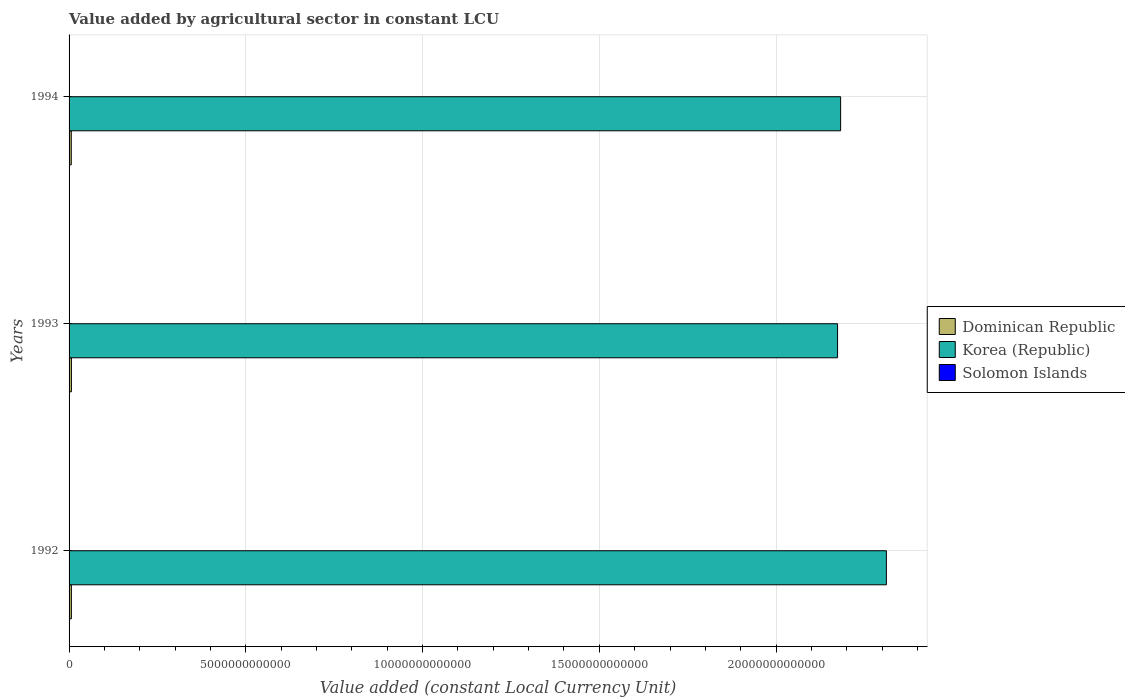How many different coloured bars are there?
Offer a very short reply. 3. Are the number of bars per tick equal to the number of legend labels?
Offer a terse response. Yes. Are the number of bars on each tick of the Y-axis equal?
Offer a very short reply. Yes. How many bars are there on the 2nd tick from the bottom?
Make the answer very short. 3. What is the value added by agricultural sector in Dominican Republic in 1993?
Provide a succinct answer. 6.63e+1. Across all years, what is the maximum value added by agricultural sector in Solomon Islands?
Keep it short and to the point. 7.80e+08. Across all years, what is the minimum value added by agricultural sector in Korea (Republic)?
Keep it short and to the point. 2.17e+13. In which year was the value added by agricultural sector in Solomon Islands minimum?
Offer a very short reply. 1993. What is the total value added by agricultural sector in Dominican Republic in the graph?
Your answer should be compact. 1.94e+11. What is the difference between the value added by agricultural sector in Solomon Islands in 1993 and that in 1994?
Offer a terse response. -1.14e+08. What is the difference between the value added by agricultural sector in Solomon Islands in 1992 and the value added by agricultural sector in Korea (Republic) in 1994?
Your answer should be compact. -2.18e+13. What is the average value added by agricultural sector in Dominican Republic per year?
Offer a very short reply. 6.46e+1. In the year 1994, what is the difference between the value added by agricultural sector in Solomon Islands and value added by agricultural sector in Korea (Republic)?
Your answer should be compact. -2.18e+13. What is the ratio of the value added by agricultural sector in Solomon Islands in 1992 to that in 1994?
Make the answer very short. 0.91. Is the difference between the value added by agricultural sector in Solomon Islands in 1993 and 1994 greater than the difference between the value added by agricultural sector in Korea (Republic) in 1993 and 1994?
Keep it short and to the point. Yes. What is the difference between the highest and the second highest value added by agricultural sector in Solomon Islands?
Provide a succinct answer. 7.21e+07. What is the difference between the highest and the lowest value added by agricultural sector in Dominican Republic?
Make the answer very short. 4.11e+09. In how many years, is the value added by agricultural sector in Korea (Republic) greater than the average value added by agricultural sector in Korea (Republic) taken over all years?
Make the answer very short. 1. What does the 3rd bar from the top in 1993 represents?
Make the answer very short. Dominican Republic. Is it the case that in every year, the sum of the value added by agricultural sector in Solomon Islands and value added by agricultural sector in Korea (Republic) is greater than the value added by agricultural sector in Dominican Republic?
Make the answer very short. Yes. How many bars are there?
Provide a succinct answer. 9. How many years are there in the graph?
Your answer should be compact. 3. What is the difference between two consecutive major ticks on the X-axis?
Ensure brevity in your answer.  5.00e+12. Does the graph contain grids?
Make the answer very short. Yes. Where does the legend appear in the graph?
Offer a terse response. Center right. How many legend labels are there?
Offer a very short reply. 3. How are the legend labels stacked?
Offer a terse response. Vertical. What is the title of the graph?
Make the answer very short. Value added by agricultural sector in constant LCU. Does "Congo (Republic)" appear as one of the legend labels in the graph?
Keep it short and to the point. No. What is the label or title of the X-axis?
Give a very brief answer. Value added (constant Local Currency Unit). What is the Value added (constant Local Currency Unit) in Dominican Republic in 1992?
Make the answer very short. 6.53e+1. What is the Value added (constant Local Currency Unit) in Korea (Republic) in 1992?
Your answer should be compact. 2.31e+13. What is the Value added (constant Local Currency Unit) in Solomon Islands in 1992?
Keep it short and to the point. 7.08e+08. What is the Value added (constant Local Currency Unit) in Dominican Republic in 1993?
Your answer should be compact. 6.63e+1. What is the Value added (constant Local Currency Unit) of Korea (Republic) in 1993?
Give a very brief answer. 2.17e+13. What is the Value added (constant Local Currency Unit) in Solomon Islands in 1993?
Provide a short and direct response. 6.66e+08. What is the Value added (constant Local Currency Unit) in Dominican Republic in 1994?
Provide a short and direct response. 6.21e+1. What is the Value added (constant Local Currency Unit) in Korea (Republic) in 1994?
Offer a terse response. 2.18e+13. What is the Value added (constant Local Currency Unit) in Solomon Islands in 1994?
Make the answer very short. 7.80e+08. Across all years, what is the maximum Value added (constant Local Currency Unit) of Dominican Republic?
Your answer should be compact. 6.63e+1. Across all years, what is the maximum Value added (constant Local Currency Unit) in Korea (Republic)?
Keep it short and to the point. 2.31e+13. Across all years, what is the maximum Value added (constant Local Currency Unit) of Solomon Islands?
Keep it short and to the point. 7.80e+08. Across all years, what is the minimum Value added (constant Local Currency Unit) in Dominican Republic?
Ensure brevity in your answer.  6.21e+1. Across all years, what is the minimum Value added (constant Local Currency Unit) of Korea (Republic)?
Keep it short and to the point. 2.17e+13. Across all years, what is the minimum Value added (constant Local Currency Unit) in Solomon Islands?
Keep it short and to the point. 6.66e+08. What is the total Value added (constant Local Currency Unit) in Dominican Republic in the graph?
Ensure brevity in your answer.  1.94e+11. What is the total Value added (constant Local Currency Unit) of Korea (Republic) in the graph?
Your response must be concise. 6.67e+13. What is the total Value added (constant Local Currency Unit) in Solomon Islands in the graph?
Keep it short and to the point. 2.15e+09. What is the difference between the Value added (constant Local Currency Unit) of Dominican Republic in 1992 and that in 1993?
Give a very brief answer. -9.37e+08. What is the difference between the Value added (constant Local Currency Unit) of Korea (Republic) in 1992 and that in 1993?
Your response must be concise. 1.38e+12. What is the difference between the Value added (constant Local Currency Unit) of Solomon Islands in 1992 and that in 1993?
Provide a succinct answer. 4.16e+07. What is the difference between the Value added (constant Local Currency Unit) in Dominican Republic in 1992 and that in 1994?
Ensure brevity in your answer.  3.17e+09. What is the difference between the Value added (constant Local Currency Unit) of Korea (Republic) in 1992 and that in 1994?
Offer a terse response. 1.29e+12. What is the difference between the Value added (constant Local Currency Unit) of Solomon Islands in 1992 and that in 1994?
Make the answer very short. -7.21e+07. What is the difference between the Value added (constant Local Currency Unit) of Dominican Republic in 1993 and that in 1994?
Provide a short and direct response. 4.11e+09. What is the difference between the Value added (constant Local Currency Unit) in Korea (Republic) in 1993 and that in 1994?
Provide a short and direct response. -8.64e+1. What is the difference between the Value added (constant Local Currency Unit) of Solomon Islands in 1993 and that in 1994?
Provide a succinct answer. -1.14e+08. What is the difference between the Value added (constant Local Currency Unit) of Dominican Republic in 1992 and the Value added (constant Local Currency Unit) of Korea (Republic) in 1993?
Offer a terse response. -2.17e+13. What is the difference between the Value added (constant Local Currency Unit) in Dominican Republic in 1992 and the Value added (constant Local Currency Unit) in Solomon Islands in 1993?
Make the answer very short. 6.47e+1. What is the difference between the Value added (constant Local Currency Unit) of Korea (Republic) in 1992 and the Value added (constant Local Currency Unit) of Solomon Islands in 1993?
Your answer should be very brief. 2.31e+13. What is the difference between the Value added (constant Local Currency Unit) of Dominican Republic in 1992 and the Value added (constant Local Currency Unit) of Korea (Republic) in 1994?
Offer a terse response. -2.18e+13. What is the difference between the Value added (constant Local Currency Unit) in Dominican Republic in 1992 and the Value added (constant Local Currency Unit) in Solomon Islands in 1994?
Make the answer very short. 6.45e+1. What is the difference between the Value added (constant Local Currency Unit) in Korea (Republic) in 1992 and the Value added (constant Local Currency Unit) in Solomon Islands in 1994?
Your answer should be compact. 2.31e+13. What is the difference between the Value added (constant Local Currency Unit) of Dominican Republic in 1993 and the Value added (constant Local Currency Unit) of Korea (Republic) in 1994?
Your response must be concise. -2.18e+13. What is the difference between the Value added (constant Local Currency Unit) in Dominican Republic in 1993 and the Value added (constant Local Currency Unit) in Solomon Islands in 1994?
Provide a succinct answer. 6.55e+1. What is the difference between the Value added (constant Local Currency Unit) of Korea (Republic) in 1993 and the Value added (constant Local Currency Unit) of Solomon Islands in 1994?
Your answer should be very brief. 2.17e+13. What is the average Value added (constant Local Currency Unit) in Dominican Republic per year?
Keep it short and to the point. 6.46e+1. What is the average Value added (constant Local Currency Unit) of Korea (Republic) per year?
Your response must be concise. 2.22e+13. What is the average Value added (constant Local Currency Unit) in Solomon Islands per year?
Provide a short and direct response. 7.18e+08. In the year 1992, what is the difference between the Value added (constant Local Currency Unit) in Dominican Republic and Value added (constant Local Currency Unit) in Korea (Republic)?
Offer a terse response. -2.31e+13. In the year 1992, what is the difference between the Value added (constant Local Currency Unit) of Dominican Republic and Value added (constant Local Currency Unit) of Solomon Islands?
Ensure brevity in your answer.  6.46e+1. In the year 1992, what is the difference between the Value added (constant Local Currency Unit) in Korea (Republic) and Value added (constant Local Currency Unit) in Solomon Islands?
Give a very brief answer. 2.31e+13. In the year 1993, what is the difference between the Value added (constant Local Currency Unit) of Dominican Republic and Value added (constant Local Currency Unit) of Korea (Republic)?
Make the answer very short. -2.17e+13. In the year 1993, what is the difference between the Value added (constant Local Currency Unit) of Dominican Republic and Value added (constant Local Currency Unit) of Solomon Islands?
Your response must be concise. 6.56e+1. In the year 1993, what is the difference between the Value added (constant Local Currency Unit) in Korea (Republic) and Value added (constant Local Currency Unit) in Solomon Islands?
Your answer should be very brief. 2.17e+13. In the year 1994, what is the difference between the Value added (constant Local Currency Unit) of Dominican Republic and Value added (constant Local Currency Unit) of Korea (Republic)?
Keep it short and to the point. -2.18e+13. In the year 1994, what is the difference between the Value added (constant Local Currency Unit) in Dominican Republic and Value added (constant Local Currency Unit) in Solomon Islands?
Give a very brief answer. 6.14e+1. In the year 1994, what is the difference between the Value added (constant Local Currency Unit) of Korea (Republic) and Value added (constant Local Currency Unit) of Solomon Islands?
Give a very brief answer. 2.18e+13. What is the ratio of the Value added (constant Local Currency Unit) in Dominican Republic in 1992 to that in 1993?
Offer a very short reply. 0.99. What is the ratio of the Value added (constant Local Currency Unit) of Korea (Republic) in 1992 to that in 1993?
Make the answer very short. 1.06. What is the ratio of the Value added (constant Local Currency Unit) of Solomon Islands in 1992 to that in 1993?
Your response must be concise. 1.06. What is the ratio of the Value added (constant Local Currency Unit) in Dominican Republic in 1992 to that in 1994?
Ensure brevity in your answer.  1.05. What is the ratio of the Value added (constant Local Currency Unit) in Korea (Republic) in 1992 to that in 1994?
Ensure brevity in your answer.  1.06. What is the ratio of the Value added (constant Local Currency Unit) in Solomon Islands in 1992 to that in 1994?
Offer a terse response. 0.91. What is the ratio of the Value added (constant Local Currency Unit) in Dominican Republic in 1993 to that in 1994?
Your response must be concise. 1.07. What is the ratio of the Value added (constant Local Currency Unit) in Korea (Republic) in 1993 to that in 1994?
Give a very brief answer. 1. What is the ratio of the Value added (constant Local Currency Unit) in Solomon Islands in 1993 to that in 1994?
Your answer should be very brief. 0.85. What is the difference between the highest and the second highest Value added (constant Local Currency Unit) in Dominican Republic?
Provide a short and direct response. 9.37e+08. What is the difference between the highest and the second highest Value added (constant Local Currency Unit) in Korea (Republic)?
Make the answer very short. 1.29e+12. What is the difference between the highest and the second highest Value added (constant Local Currency Unit) in Solomon Islands?
Your answer should be compact. 7.21e+07. What is the difference between the highest and the lowest Value added (constant Local Currency Unit) in Dominican Republic?
Offer a terse response. 4.11e+09. What is the difference between the highest and the lowest Value added (constant Local Currency Unit) of Korea (Republic)?
Offer a terse response. 1.38e+12. What is the difference between the highest and the lowest Value added (constant Local Currency Unit) in Solomon Islands?
Make the answer very short. 1.14e+08. 